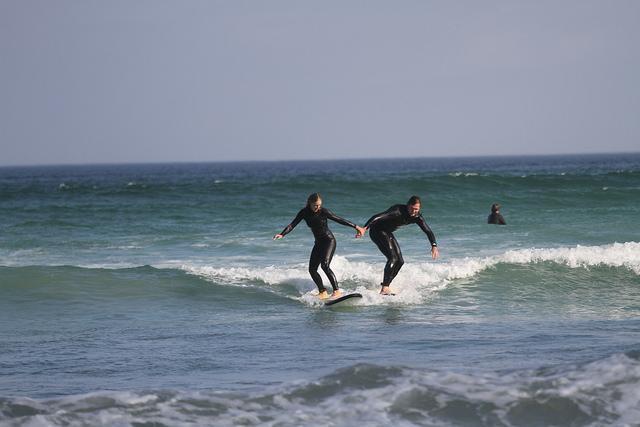How many women are surfing?
Give a very brief answer. 2. How many people are on surfboards?
Give a very brief answer. 2. How many people are there?
Give a very brief answer. 2. 